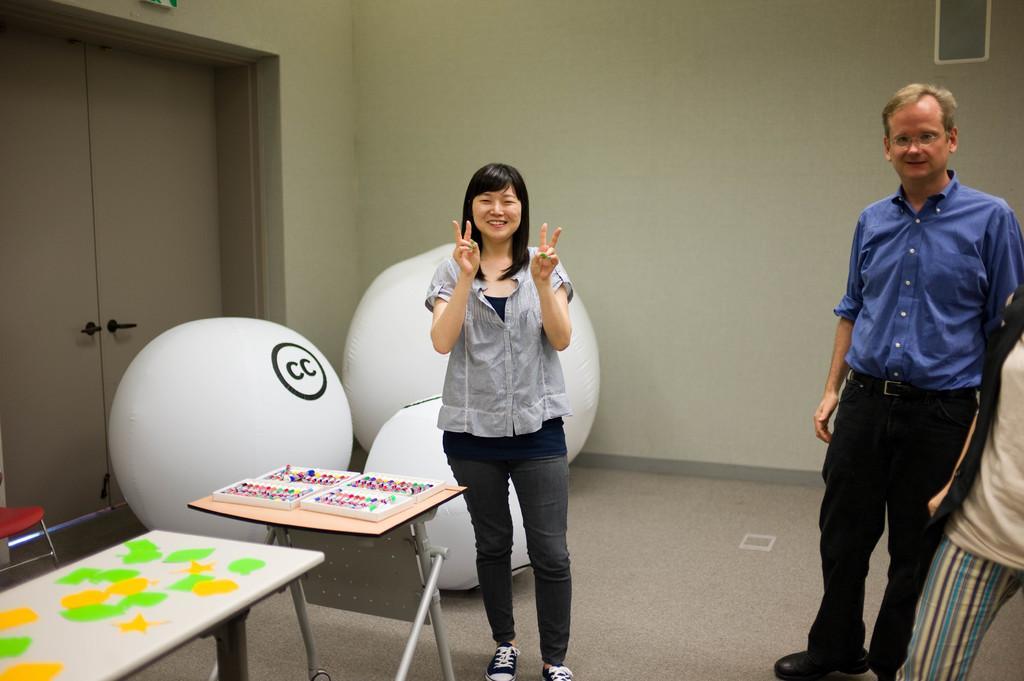How would you summarize this image in a sentence or two? In this picture two people are standing and there are three big white balls placed in the background , on top of which cc has been written. There are also few tables on top of which objects are placed. In the background there is a door. 